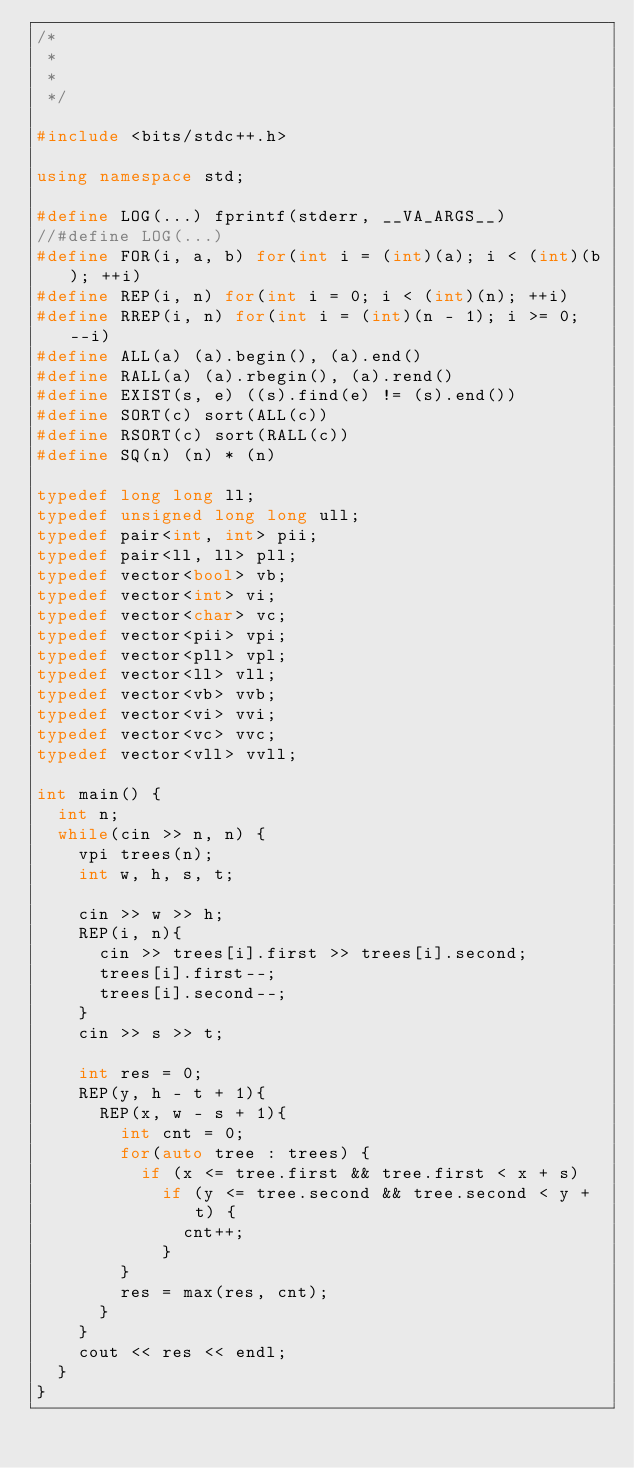<code> <loc_0><loc_0><loc_500><loc_500><_C++_>/*
 *
 *
 */

#include <bits/stdc++.h>

using namespace std;

#define LOG(...) fprintf(stderr, __VA_ARGS__)
//#define LOG(...)
#define FOR(i, a, b) for(int i = (int)(a); i < (int)(b); ++i)
#define REP(i, n) for(int i = 0; i < (int)(n); ++i)
#define RREP(i, n) for(int i = (int)(n - 1); i >= 0; --i)
#define ALL(a) (a).begin(), (a).end()
#define RALL(a) (a).rbegin(), (a).rend()
#define EXIST(s, e) ((s).find(e) != (s).end())
#define SORT(c) sort(ALL(c))
#define RSORT(c) sort(RALL(c))
#define SQ(n) (n) * (n)

typedef long long ll;
typedef unsigned long long ull;
typedef pair<int, int> pii;
typedef pair<ll, ll> pll;
typedef vector<bool> vb;
typedef vector<int> vi;
typedef vector<char> vc;
typedef vector<pii> vpi;
typedef vector<pll> vpl;
typedef vector<ll> vll;
typedef vector<vb> vvb;
typedef vector<vi> vvi;
typedef vector<vc> vvc;
typedef vector<vll> vvll;

int main() {
  int n;
  while(cin >> n, n) {
    vpi trees(n);
    int w, h, s, t;

    cin >> w >> h;
    REP(i, n){
      cin >> trees[i].first >> trees[i].second;
      trees[i].first--;
      trees[i].second--;
    }
    cin >> s >> t;

    int res = 0;
    REP(y, h - t + 1){
      REP(x, w - s + 1){
        int cnt = 0;
        for(auto tree : trees) {
          if (x <= tree.first && tree.first < x + s)
            if (y <= tree.second && tree.second < y + t) {
              cnt++;
            }
        }
        res = max(res, cnt);
      }
    }
    cout << res << endl;
  }
}</code> 